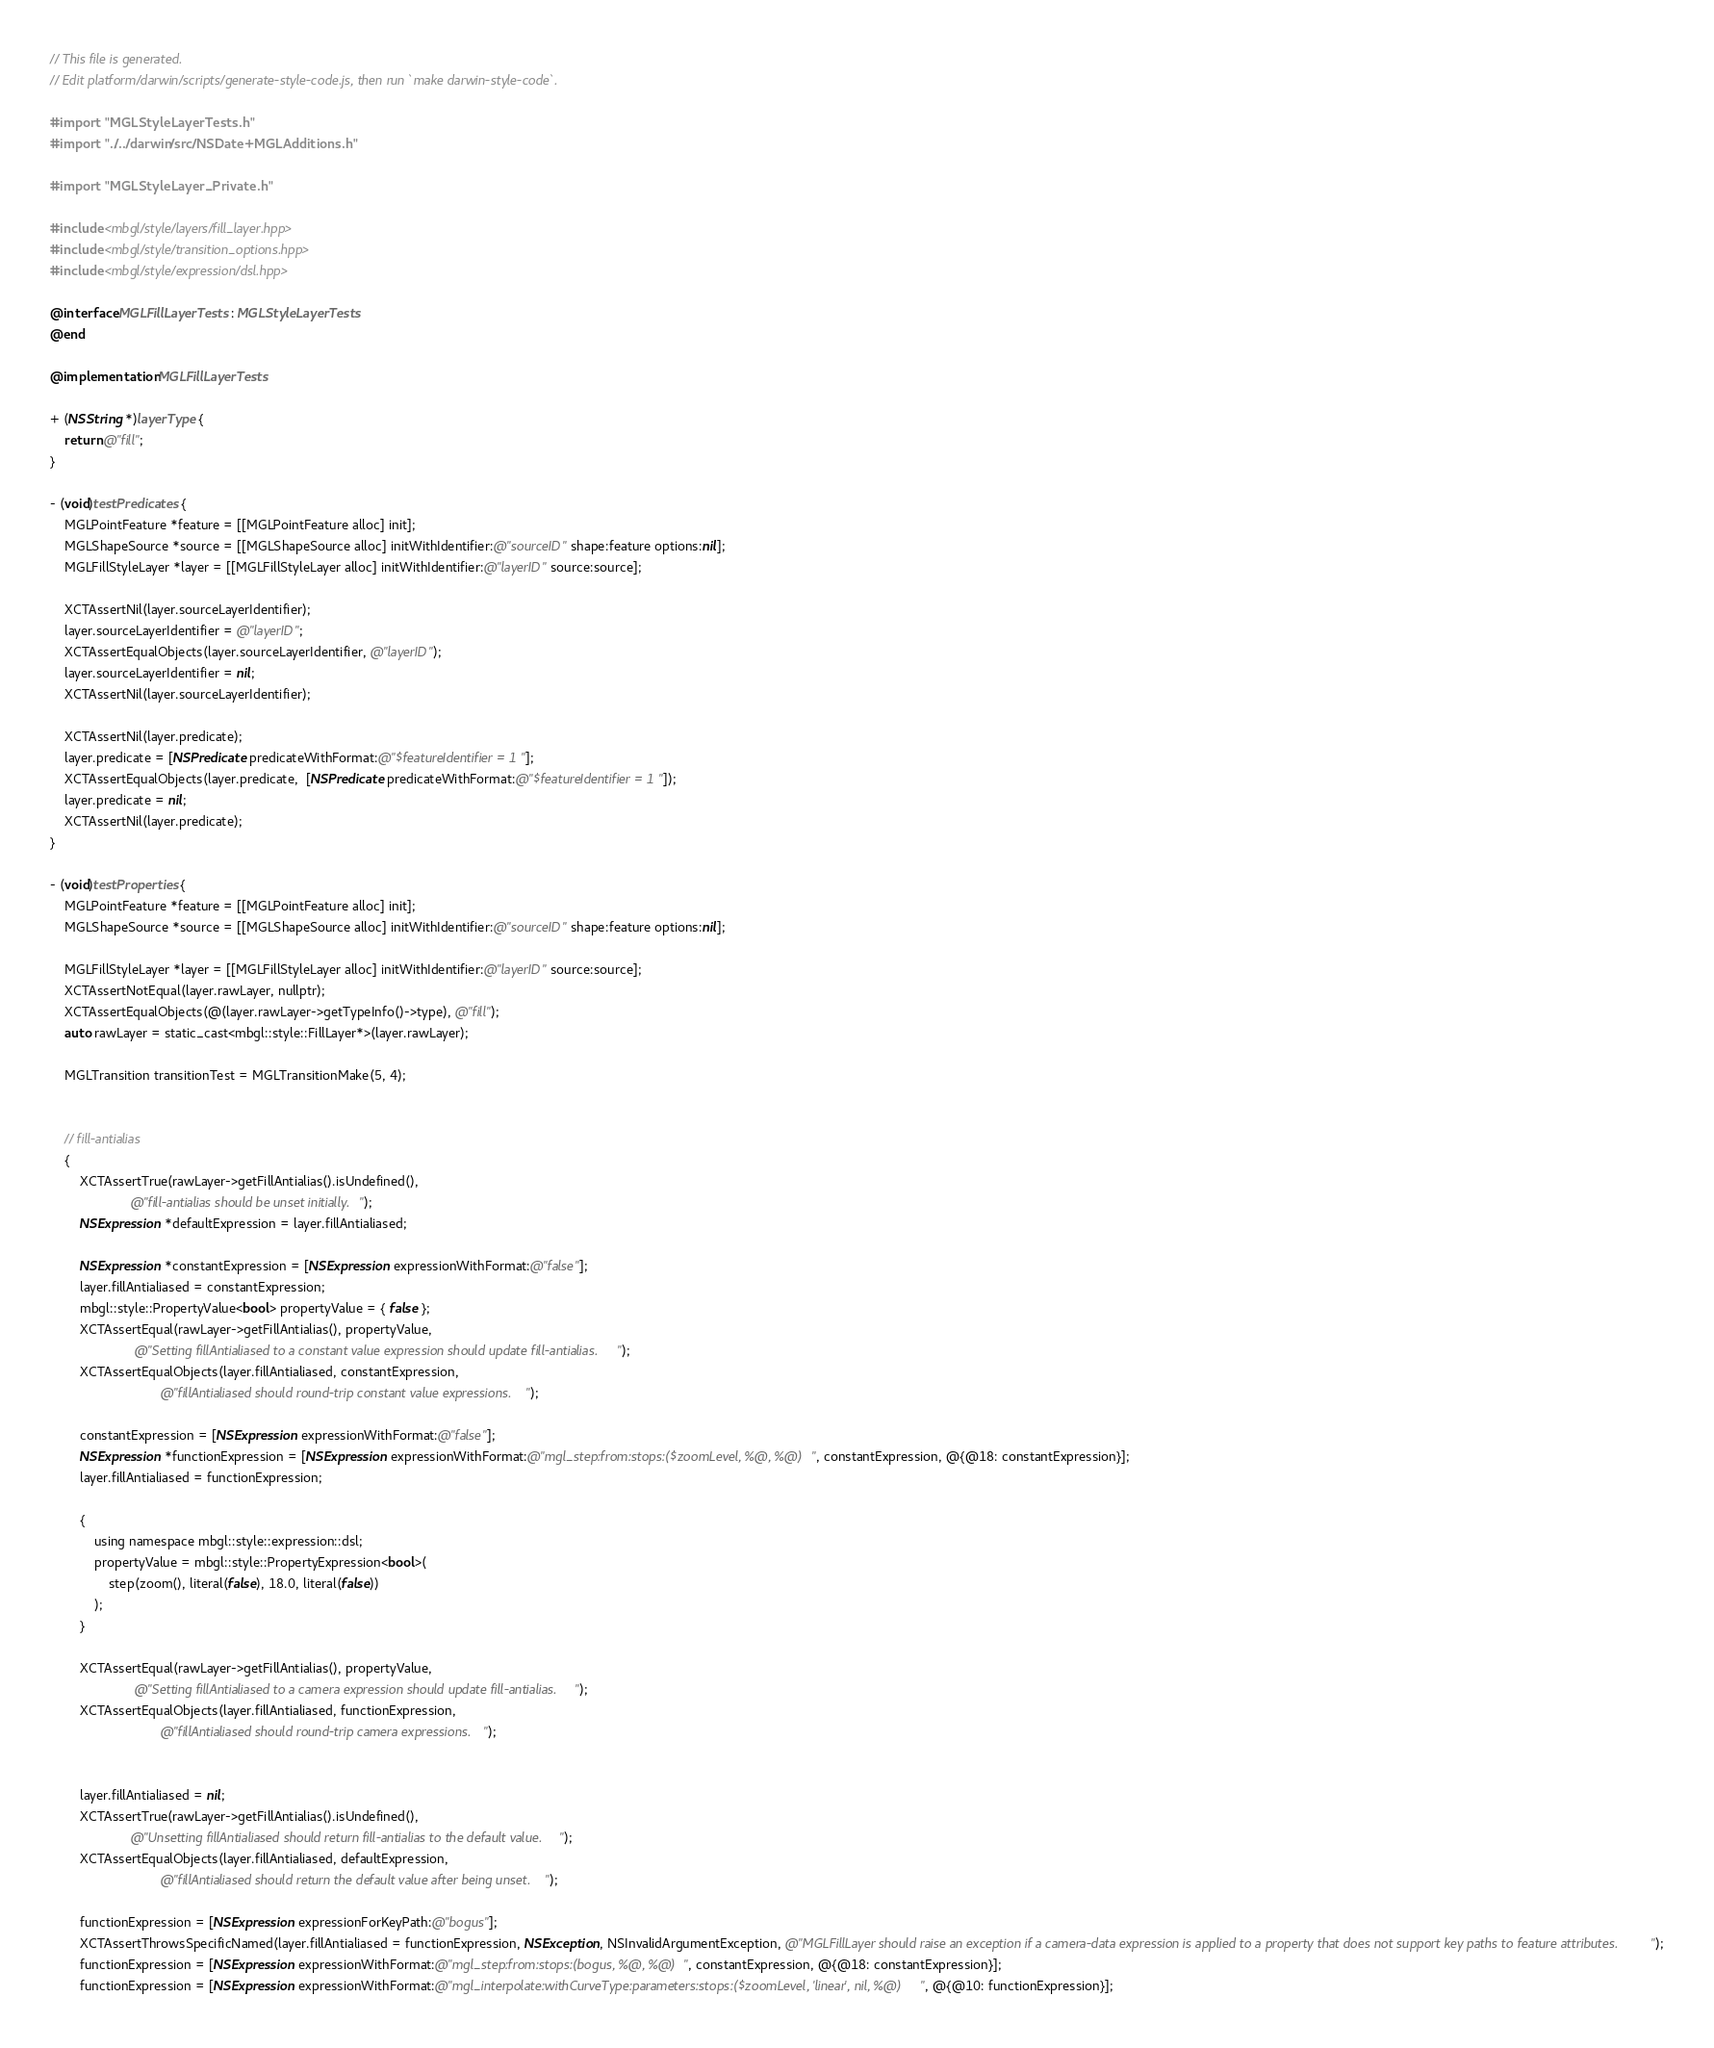Convert code to text. <code><loc_0><loc_0><loc_500><loc_500><_ObjectiveC_>// This file is generated.
// Edit platform/darwin/scripts/generate-style-code.js, then run `make darwin-style-code`.

#import "MGLStyleLayerTests.h"
#import "../../darwin/src/NSDate+MGLAdditions.h"

#import "MGLStyleLayer_Private.h"

#include <mbgl/style/layers/fill_layer.hpp>
#include <mbgl/style/transition_options.hpp>
#include <mbgl/style/expression/dsl.hpp>

@interface MGLFillLayerTests : MGLStyleLayerTests
@end

@implementation MGLFillLayerTests

+ (NSString *)layerType {
    return @"fill";
}

- (void)testPredicates {
    MGLPointFeature *feature = [[MGLPointFeature alloc] init];
    MGLShapeSource *source = [[MGLShapeSource alloc] initWithIdentifier:@"sourceID" shape:feature options:nil];
    MGLFillStyleLayer *layer = [[MGLFillStyleLayer alloc] initWithIdentifier:@"layerID" source:source];

    XCTAssertNil(layer.sourceLayerIdentifier);
    layer.sourceLayerIdentifier = @"layerID";
    XCTAssertEqualObjects(layer.sourceLayerIdentifier, @"layerID");
    layer.sourceLayerIdentifier = nil;
    XCTAssertNil(layer.sourceLayerIdentifier);

    XCTAssertNil(layer.predicate);
    layer.predicate = [NSPredicate predicateWithFormat:@"$featureIdentifier = 1"];
    XCTAssertEqualObjects(layer.predicate,  [NSPredicate predicateWithFormat:@"$featureIdentifier = 1"]);
    layer.predicate = nil;
    XCTAssertNil(layer.predicate);
}

- (void)testProperties {
    MGLPointFeature *feature = [[MGLPointFeature alloc] init];
    MGLShapeSource *source = [[MGLShapeSource alloc] initWithIdentifier:@"sourceID" shape:feature options:nil];

    MGLFillStyleLayer *layer = [[MGLFillStyleLayer alloc] initWithIdentifier:@"layerID" source:source];
    XCTAssertNotEqual(layer.rawLayer, nullptr);
    XCTAssertEqualObjects(@(layer.rawLayer->getTypeInfo()->type), @"fill");
    auto rawLayer = static_cast<mbgl::style::FillLayer*>(layer.rawLayer);

    MGLTransition transitionTest = MGLTransitionMake(5, 4);


    // fill-antialias
    {
        XCTAssertTrue(rawLayer->getFillAntialias().isUndefined(),
                      @"fill-antialias should be unset initially.");
        NSExpression *defaultExpression = layer.fillAntialiased;

        NSExpression *constantExpression = [NSExpression expressionWithFormat:@"false"];
        layer.fillAntialiased = constantExpression;
        mbgl::style::PropertyValue<bool> propertyValue = { false };
        XCTAssertEqual(rawLayer->getFillAntialias(), propertyValue,
                       @"Setting fillAntialiased to a constant value expression should update fill-antialias.");
        XCTAssertEqualObjects(layer.fillAntialiased, constantExpression,
                              @"fillAntialiased should round-trip constant value expressions.");

        constantExpression = [NSExpression expressionWithFormat:@"false"];
        NSExpression *functionExpression = [NSExpression expressionWithFormat:@"mgl_step:from:stops:($zoomLevel, %@, %@)", constantExpression, @{@18: constantExpression}];
        layer.fillAntialiased = functionExpression;

        {
            using namespace mbgl::style::expression::dsl;
            propertyValue = mbgl::style::PropertyExpression<bool>(
                step(zoom(), literal(false), 18.0, literal(false))
            );
        }

        XCTAssertEqual(rawLayer->getFillAntialias(), propertyValue,
                       @"Setting fillAntialiased to a camera expression should update fill-antialias.");
        XCTAssertEqualObjects(layer.fillAntialiased, functionExpression,
                              @"fillAntialiased should round-trip camera expressions.");


        layer.fillAntialiased = nil;
        XCTAssertTrue(rawLayer->getFillAntialias().isUndefined(),
                      @"Unsetting fillAntialiased should return fill-antialias to the default value.");
        XCTAssertEqualObjects(layer.fillAntialiased, defaultExpression,
                              @"fillAntialiased should return the default value after being unset.");

        functionExpression = [NSExpression expressionForKeyPath:@"bogus"];
        XCTAssertThrowsSpecificNamed(layer.fillAntialiased = functionExpression, NSException, NSInvalidArgumentException, @"MGLFillLayer should raise an exception if a camera-data expression is applied to a property that does not support key paths to feature attributes.");
        functionExpression = [NSExpression expressionWithFormat:@"mgl_step:from:stops:(bogus, %@, %@)", constantExpression, @{@18: constantExpression}];
        functionExpression = [NSExpression expressionWithFormat:@"mgl_interpolate:withCurveType:parameters:stops:($zoomLevel, 'linear', nil, %@)", @{@10: functionExpression}];</code> 